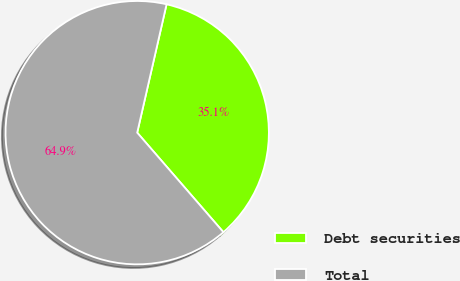<chart> <loc_0><loc_0><loc_500><loc_500><pie_chart><fcel>Debt securities<fcel>Total<nl><fcel>35.06%<fcel>64.94%<nl></chart> 